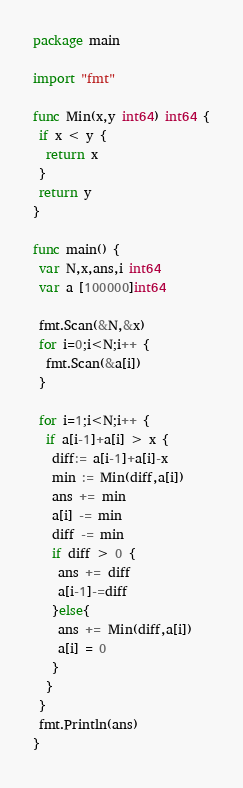Convert code to text. <code><loc_0><loc_0><loc_500><loc_500><_Go_>package main

import "fmt"

func Min(x,y int64) int64 {
 if x < y {
  return x
 }
 return y
}

func main() {
 var N,x,ans,i int64
 var a [100000]int64

 fmt.Scan(&N,&x)
 for i=0;i<N;i++ {
  fmt.Scan(&a[i])
 }

 for i=1;i<N;i++ {
  if a[i-1]+a[i] > x {
   diff:= a[i-1]+a[i]-x
   min := Min(diff,a[i])
   ans += min
   a[i] -= min
   diff -= min
   if diff > 0 {
    ans += diff
    a[i-1]-=diff
   }else{
    ans += Min(diff,a[i])
    a[i] = 0
   }
  }
 }
 fmt.Println(ans)
}</code> 